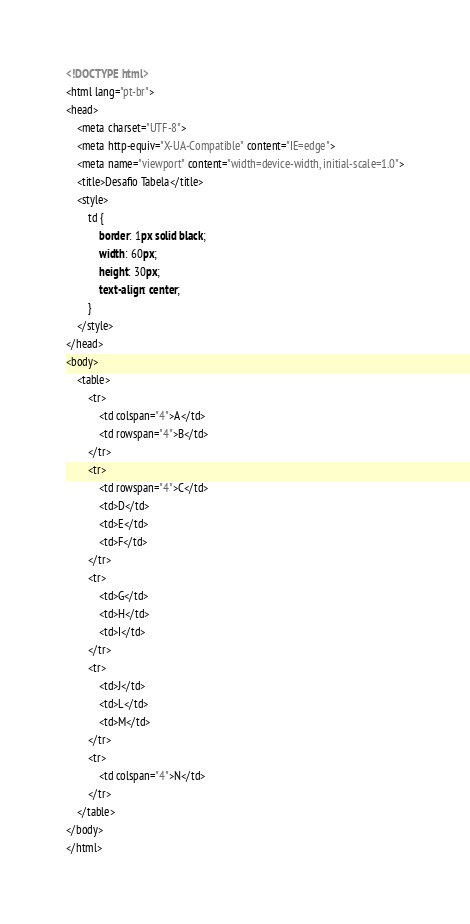Convert code to text. <code><loc_0><loc_0><loc_500><loc_500><_HTML_><!DOCTYPE html>
<html lang="pt-br">
<head>
    <meta charset="UTF-8">
    <meta http-equiv="X-UA-Compatible" content="IE=edge">
    <meta name="viewport" content="width=device-width, initial-scale=1.0">
    <title>Desafio Tabela</title>
    <style>
        td {
            border: 1px solid black;
            width: 60px;
            height: 30px;
            text-align: center;
        }
    </style>
</head>
<body>
    <table>
        <tr>
            <td colspan="4">A</td>
            <td rowspan="4">B</td>
        </tr>
        <tr>
            <td rowspan="4">C</td>
            <td>D</td>
            <td>E</td>
            <td>F</td>
        </tr>
        <tr>
            <td>G</td>
            <td>H</td>
            <td>I</td>
        </tr>
        <tr>
            <td>J</td>
            <td>L</td>
            <td>M</td>
        </tr>
        <tr>
            <td colspan="4">N</td>
        </tr>
    </table>
</body>
</html></code> 